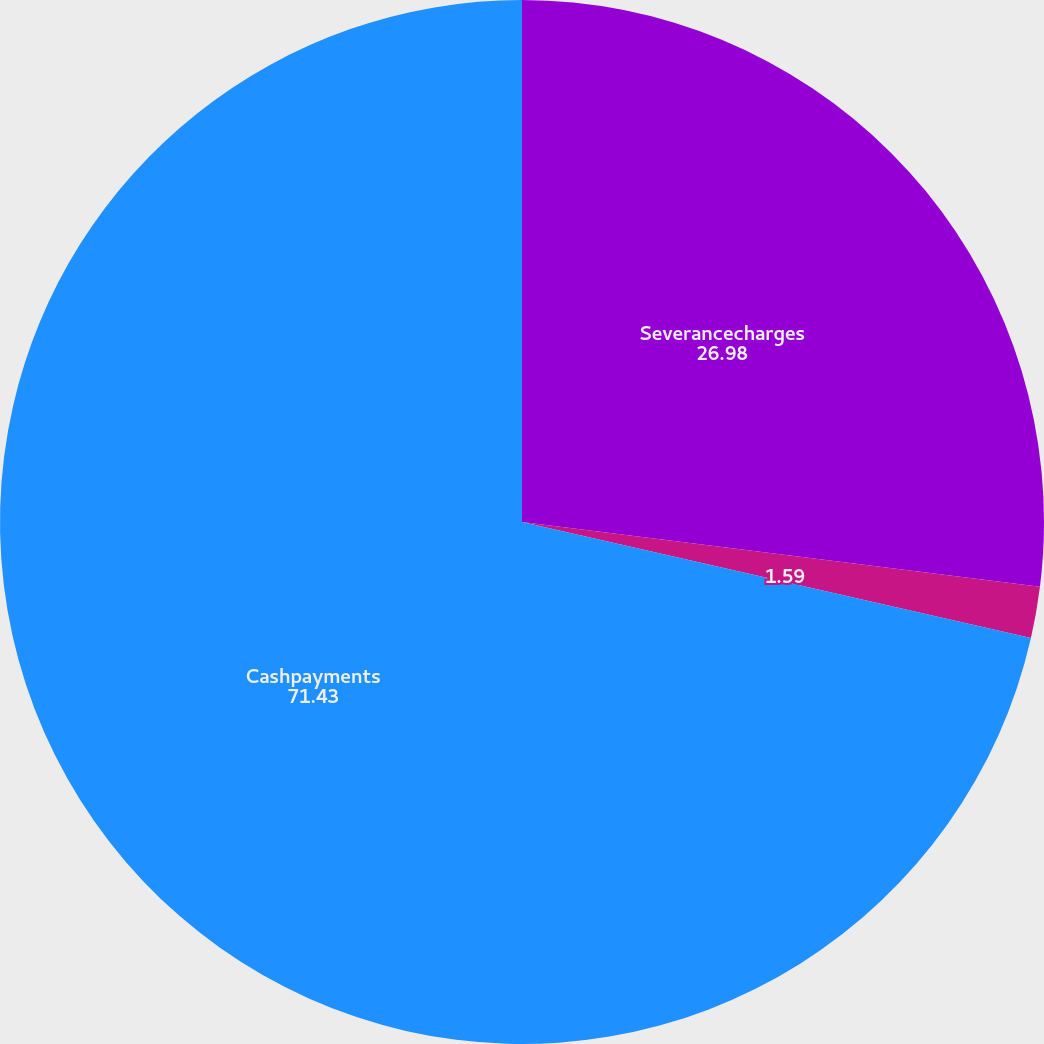Convert chart. <chart><loc_0><loc_0><loc_500><loc_500><pie_chart><fcel>Severancecharges<fcel>Unnamed: 1<fcel>Cashpayments<nl><fcel>26.98%<fcel>1.59%<fcel>71.43%<nl></chart> 